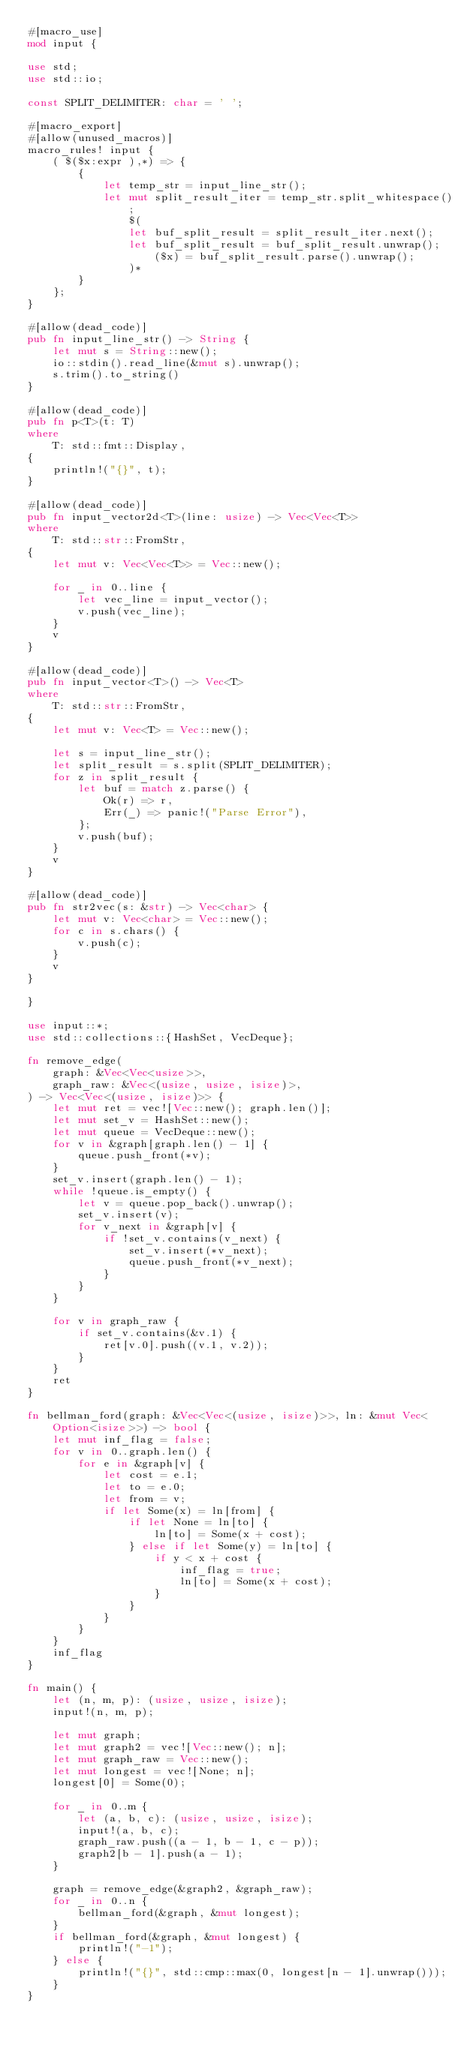<code> <loc_0><loc_0><loc_500><loc_500><_Rust_>#[macro_use]
mod input {
 
use std;
use std::io;
 
const SPLIT_DELIMITER: char = ' ';
 
#[macro_export]
#[allow(unused_macros)]
macro_rules! input {
    ( $($x:expr ),*) => {
        {
            let temp_str = input_line_str();
            let mut split_result_iter = temp_str.split_whitespace();
                $(
                let buf_split_result = split_result_iter.next();
                let buf_split_result = buf_split_result.unwrap();
                    ($x) = buf_split_result.parse().unwrap();
                )*
        }
    };
}
 
#[allow(dead_code)]
pub fn input_line_str() -> String {
    let mut s = String::new();
    io::stdin().read_line(&mut s).unwrap();
    s.trim().to_string()
}
 
#[allow(dead_code)]
pub fn p<T>(t: T)
where
    T: std::fmt::Display,
{
    println!("{}", t);
}
 
#[allow(dead_code)]
pub fn input_vector2d<T>(line: usize) -> Vec<Vec<T>>
where
    T: std::str::FromStr,
{
    let mut v: Vec<Vec<T>> = Vec::new();
 
    for _ in 0..line {
        let vec_line = input_vector();
        v.push(vec_line);
    }
    v
}
 
#[allow(dead_code)]
pub fn input_vector<T>() -> Vec<T>
where
    T: std::str::FromStr,
{
    let mut v: Vec<T> = Vec::new();
 
    let s = input_line_str();
    let split_result = s.split(SPLIT_DELIMITER);
    for z in split_result {
        let buf = match z.parse() {
            Ok(r) => r,
            Err(_) => panic!("Parse Error"),
        };
        v.push(buf);
    }
    v
}
 
#[allow(dead_code)]
pub fn str2vec(s: &str) -> Vec<char> {
    let mut v: Vec<char> = Vec::new();
    for c in s.chars() {
        v.push(c);
    }
    v
}
 
}
 
use input::*;
use std::collections::{HashSet, VecDeque};
 
fn remove_edge(
    graph: &Vec<Vec<usize>>,
    graph_raw: &Vec<(usize, usize, isize)>,
) -> Vec<Vec<(usize, isize)>> {
    let mut ret = vec![Vec::new(); graph.len()];
    let mut set_v = HashSet::new();
    let mut queue = VecDeque::new();
    for v in &graph[graph.len() - 1] {
        queue.push_front(*v);
    }
    set_v.insert(graph.len() - 1);
    while !queue.is_empty() {
        let v = queue.pop_back().unwrap();
        set_v.insert(v);
        for v_next in &graph[v] {
            if !set_v.contains(v_next) {
                set_v.insert(*v_next);
                queue.push_front(*v_next);
            }
        }
    }
 
    for v in graph_raw {
        if set_v.contains(&v.1) {
            ret[v.0].push((v.1, v.2));
        }
    }
    ret
}
 
fn bellman_ford(graph: &Vec<Vec<(usize, isize)>>, ln: &mut Vec<Option<isize>>) -> bool {
    let mut inf_flag = false;
    for v in 0..graph.len() {
        for e in &graph[v] {
            let cost = e.1;
            let to = e.0;
            let from = v;
            if let Some(x) = ln[from] {
                if let None = ln[to] {
                    ln[to] = Some(x + cost);
                } else if let Some(y) = ln[to] {
                    if y < x + cost {
                        inf_flag = true;
                        ln[to] = Some(x + cost);
                    }
                }
            }
        }
    }
    inf_flag
}
 
fn main() {
    let (n, m, p): (usize, usize, isize);
    input!(n, m, p);
 
    let mut graph;
    let mut graph2 = vec![Vec::new(); n];
    let mut graph_raw = Vec::new();
    let mut longest = vec![None; n];
    longest[0] = Some(0);
 
    for _ in 0..m {
        let (a, b, c): (usize, usize, isize);
        input!(a, b, c);
        graph_raw.push((a - 1, b - 1, c - p));
        graph2[b - 1].push(a - 1);
    }
 
    graph = remove_edge(&graph2, &graph_raw);
    for _ in 0..n {
        bellman_ford(&graph, &mut longest);
    }
    if bellman_ford(&graph, &mut longest) {
        println!("-1");
    } else {
        println!("{}", std::cmp::max(0, longest[n - 1].unwrap()));
    }
}</code> 